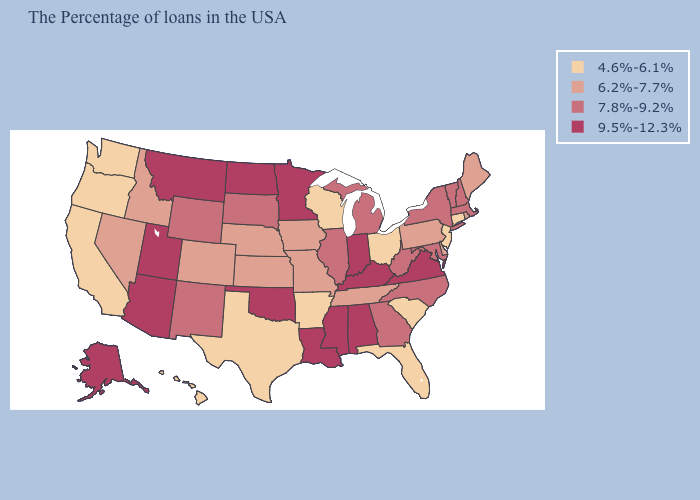Which states have the lowest value in the USA?
Answer briefly. Connecticut, New Jersey, South Carolina, Ohio, Florida, Wisconsin, Arkansas, Texas, California, Washington, Oregon, Hawaii. Among the states that border New Mexico , does Arizona have the lowest value?
Give a very brief answer. No. How many symbols are there in the legend?
Quick response, please. 4. What is the value of North Carolina?
Short answer required. 7.8%-9.2%. Does Washington have the lowest value in the USA?
Concise answer only. Yes. Does Washington have the highest value in the USA?
Answer briefly. No. Is the legend a continuous bar?
Keep it brief. No. Does Minnesota have the lowest value in the USA?
Write a very short answer. No. What is the lowest value in states that border Vermont?
Give a very brief answer. 7.8%-9.2%. What is the value of Connecticut?
Be succinct. 4.6%-6.1%. What is the value of Maryland?
Concise answer only. 7.8%-9.2%. Among the states that border New Mexico , does Utah have the highest value?
Write a very short answer. Yes. What is the value of Delaware?
Short answer required. 6.2%-7.7%. What is the value of New York?
Quick response, please. 7.8%-9.2%. What is the value of New York?
Be succinct. 7.8%-9.2%. 